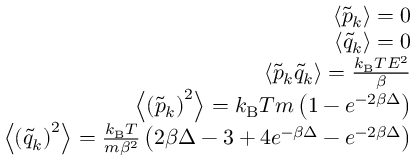Convert formula to latex. <formula><loc_0><loc_0><loc_500><loc_500>\begin{array} { r } { \left < \tilde { p } _ { k } \right > = 0 } \\ { \left < \tilde { q } _ { k } \right > = 0 } \\ { \left < \tilde { p } _ { k } \tilde { q } _ { k } \right > = \frac { k _ { B } T E ^ { 2 } } { \beta } } \\ { \left < \left ( \tilde { p } _ { k } \right ) ^ { 2 } \right > = k _ { B } T m \left ( 1 - e ^ { - 2 \beta \Delta } \right ) } \\ { \left < \left ( \tilde { q } _ { k } \right ) ^ { 2 } \right > = \frac { k _ { B } T } { m \beta ^ { 2 } } \left ( 2 \beta \Delta - 3 + 4 e ^ { - \beta \Delta } - e ^ { - 2 \beta \Delta } \right ) } \end{array}</formula> 